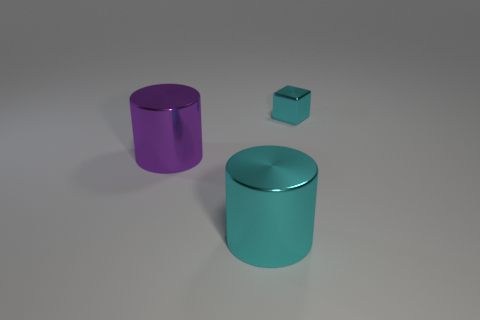There is another object that is the same shape as the purple metallic thing; what is it made of?
Make the answer very short. Metal. What is the shape of the large shiny object behind the object that is in front of the big metal cylinder that is behind the big cyan metallic cylinder?
Offer a terse response. Cylinder. Is the number of purple metal things that are in front of the purple cylinder greater than the number of small brown matte cylinders?
Make the answer very short. No. There is a cyan object that is left of the block; is its shape the same as the small cyan thing?
Make the answer very short. No. What is the cylinder in front of the purple cylinder made of?
Give a very brief answer. Metal. How many cyan objects have the same shape as the large purple shiny object?
Provide a succinct answer. 1. There is a cyan block behind the thing that is in front of the purple metal cylinder; what is it made of?
Your answer should be compact. Metal. Are there any purple cylinders that have the same material as the purple object?
Give a very brief answer. No. What is the shape of the small cyan object?
Ensure brevity in your answer.  Cube. How many large red spheres are there?
Offer a terse response. 0. 